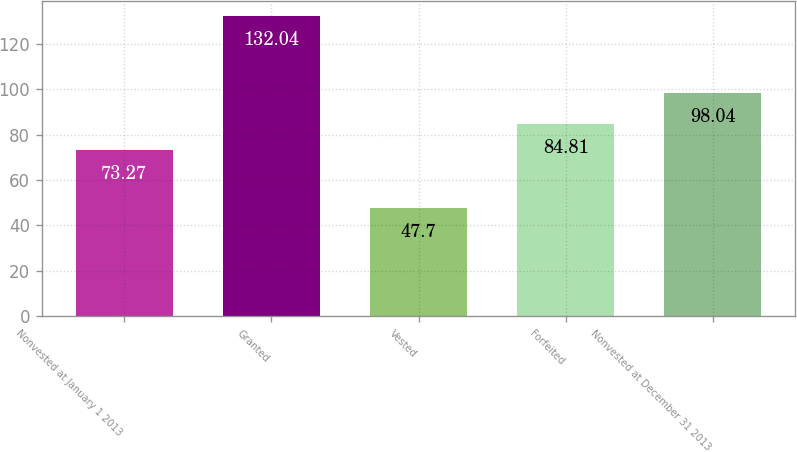Convert chart. <chart><loc_0><loc_0><loc_500><loc_500><bar_chart><fcel>Nonvested at January 1 2013<fcel>Granted<fcel>Vested<fcel>Forfeited<fcel>Nonvested at December 31 2013<nl><fcel>73.27<fcel>132.04<fcel>47.7<fcel>84.81<fcel>98.04<nl></chart> 